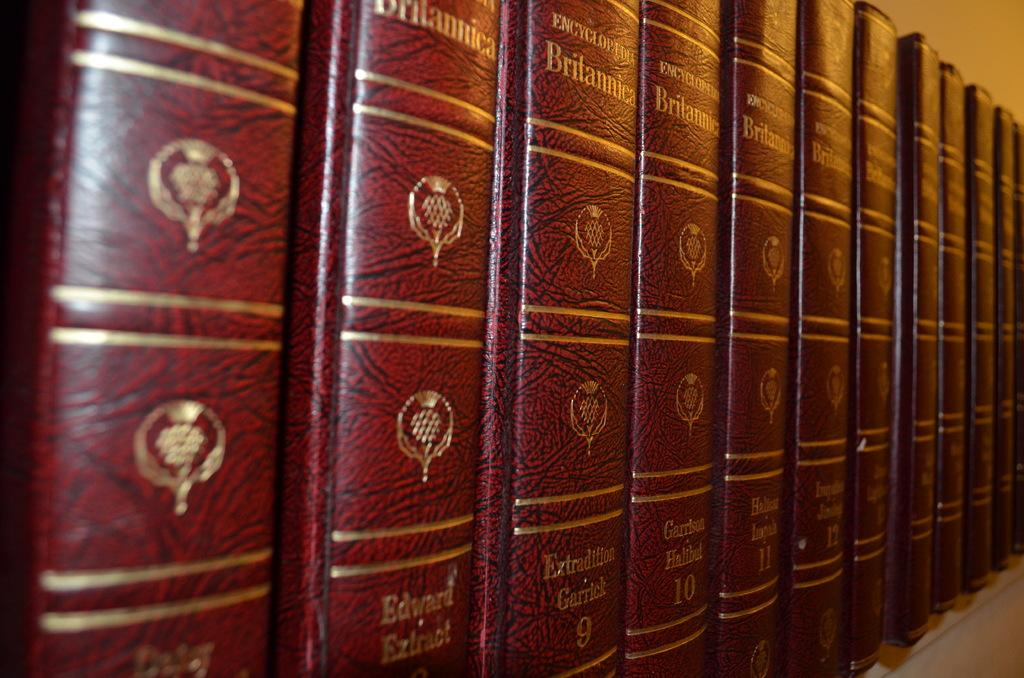<image>
Relay a brief, clear account of the picture shown. A collection of red Encyclopedia Britannica books together. 